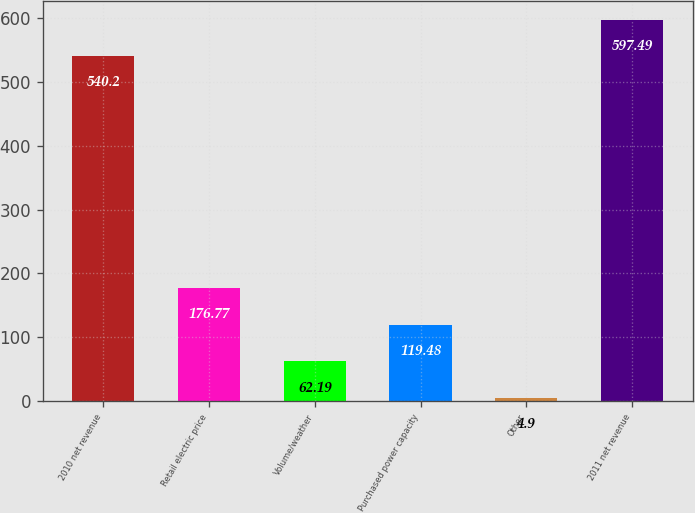<chart> <loc_0><loc_0><loc_500><loc_500><bar_chart><fcel>2010 net revenue<fcel>Retail electric price<fcel>Volume/weather<fcel>Purchased power capacity<fcel>Other<fcel>2011 net revenue<nl><fcel>540.2<fcel>176.77<fcel>62.19<fcel>119.48<fcel>4.9<fcel>597.49<nl></chart> 